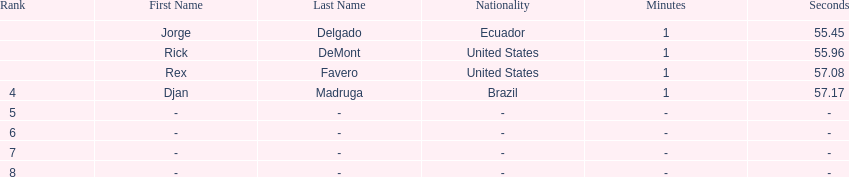What come after rex f. Djan Madruga. 